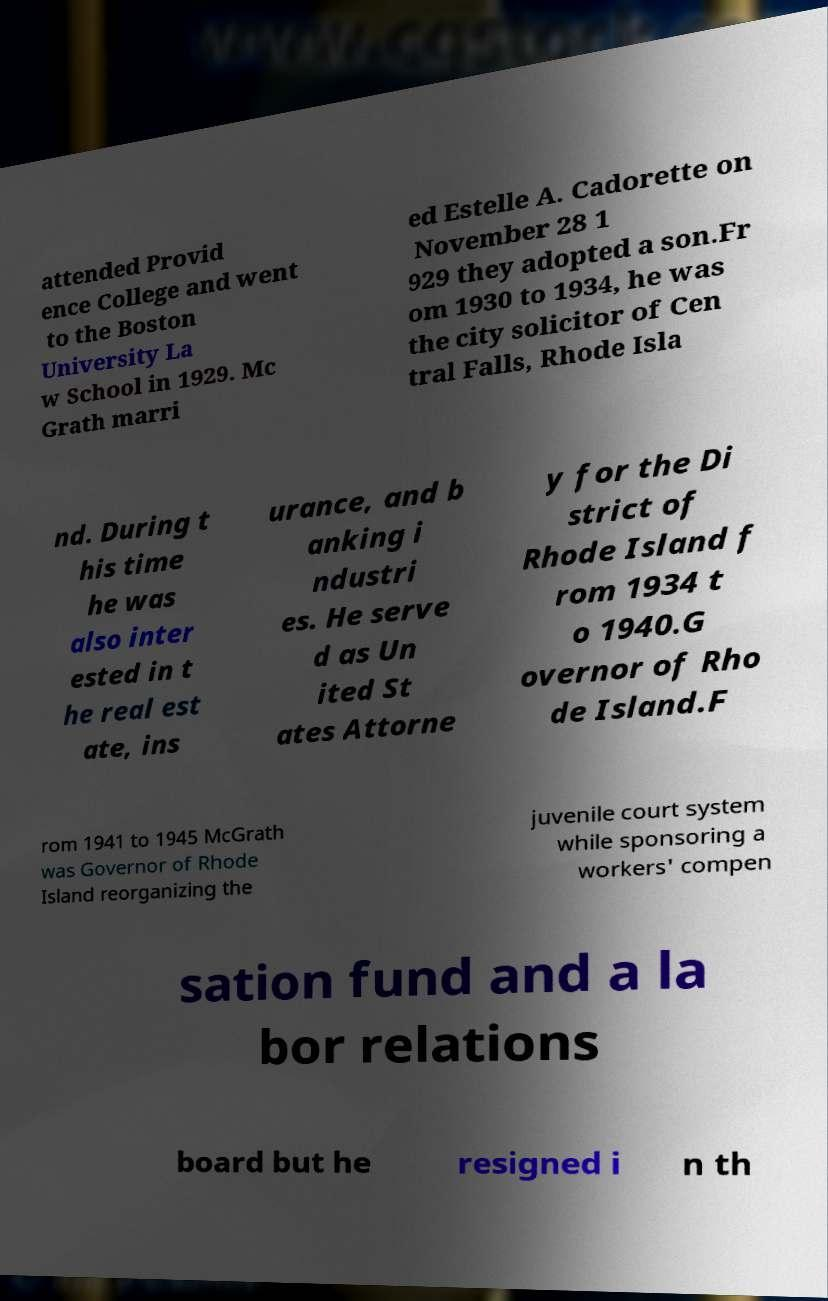For documentation purposes, I need the text within this image transcribed. Could you provide that? attended Provid ence College and went to the Boston University La w School in 1929. Mc Grath marri ed Estelle A. Cadorette on November 28 1 929 they adopted a son.Fr om 1930 to 1934, he was the city solicitor of Cen tral Falls, Rhode Isla nd. During t his time he was also inter ested in t he real est ate, ins urance, and b anking i ndustri es. He serve d as Un ited St ates Attorne y for the Di strict of Rhode Island f rom 1934 t o 1940.G overnor of Rho de Island.F rom 1941 to 1945 McGrath was Governor of Rhode Island reorganizing the juvenile court system while sponsoring a workers' compen sation fund and a la bor relations board but he resigned i n th 